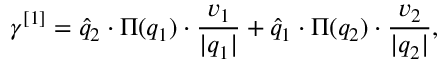<formula> <loc_0><loc_0><loc_500><loc_500>\gamma ^ { [ 1 ] } = \widehat { q } _ { 2 } \cdot \Pi ( q _ { 1 } ) \cdot \frac { v _ { 1 } } { | q _ { 1 } | } + \widehat { q } _ { 1 } \cdot \Pi ( q _ { 2 } ) \cdot \frac { v _ { 2 } } { | q _ { 2 } | } ,</formula> 